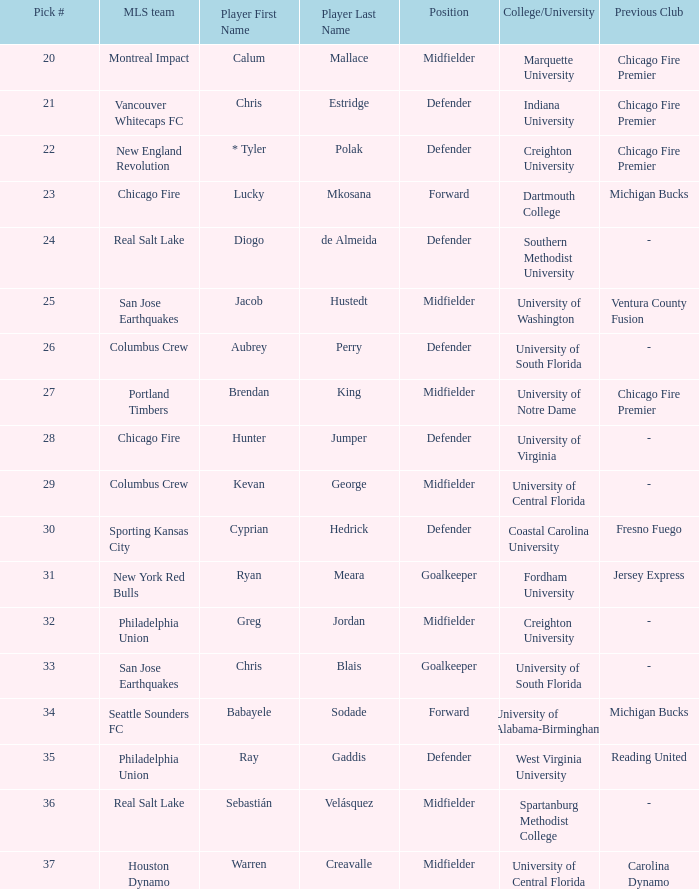What was the selection number for real salt lake? 24.0. 